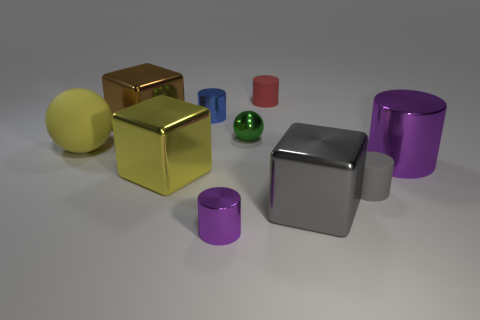Assuming these objects were used in a physics demonstration, which physical properties could they help illustrate? These objects could be used to demonstrate a variety of physical properties, such as reflection and absorption of light on different materials, the concept of center of gravity varying with shape and size, or even the basics of spatial geometry, like volume and density. Which two objects would you use to explain the concept of balance, and how? To explain the concept of balance, I would use the cylinder and the cube. By attempting to stack them in various orientations, one can illustrate how different shapes interact with each other when it comes to stability and how symmetry and center of gravity play crucial roles in maintaining balance. 